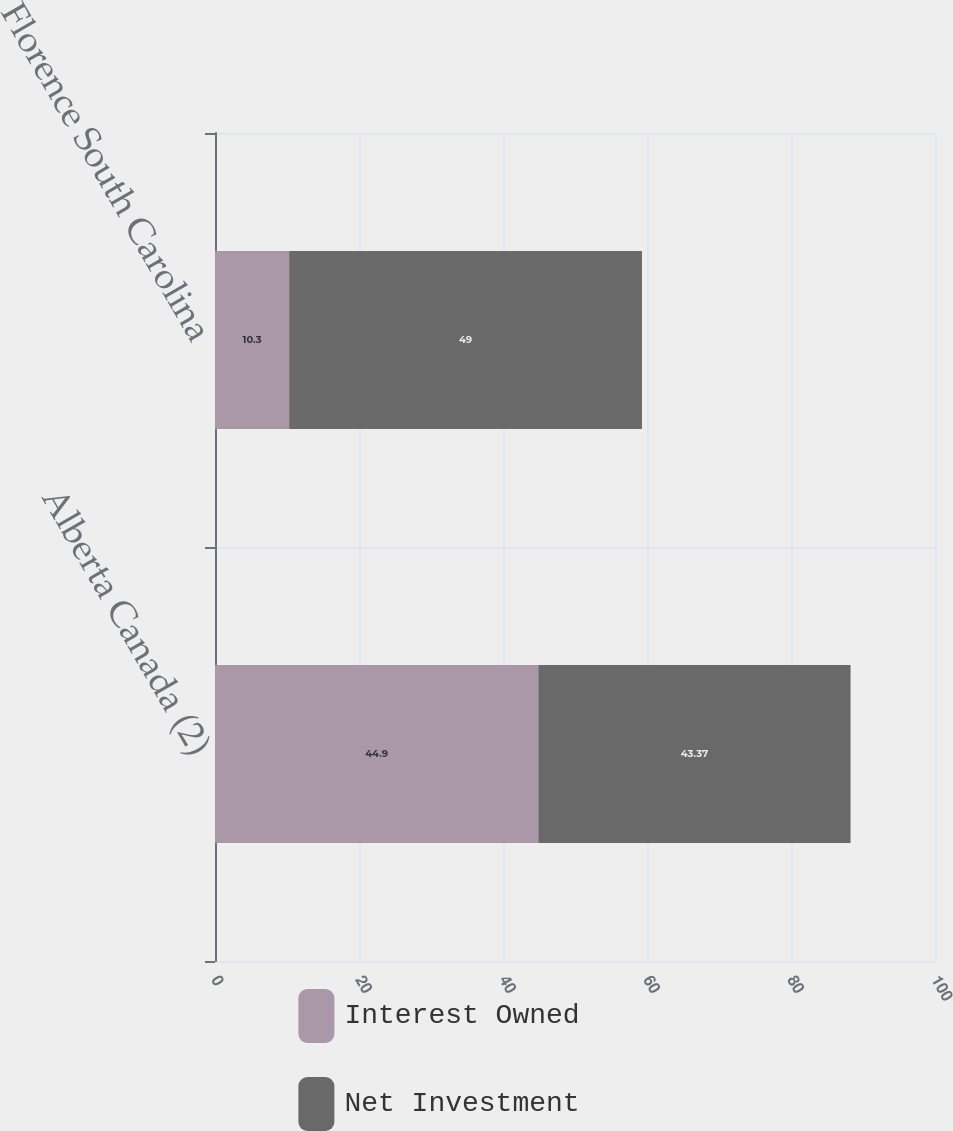Convert chart. <chart><loc_0><loc_0><loc_500><loc_500><stacked_bar_chart><ecel><fcel>Alberta Canada (2)<fcel>Florence South Carolina<nl><fcel>Interest Owned<fcel>44.9<fcel>10.3<nl><fcel>Net Investment<fcel>43.37<fcel>49<nl></chart> 